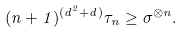Convert formula to latex. <formula><loc_0><loc_0><loc_500><loc_500>( n + 1 ) ^ { ( d ^ { 2 } + d ) } \tau _ { n } \geq \sigma ^ { \otimes n } .</formula> 